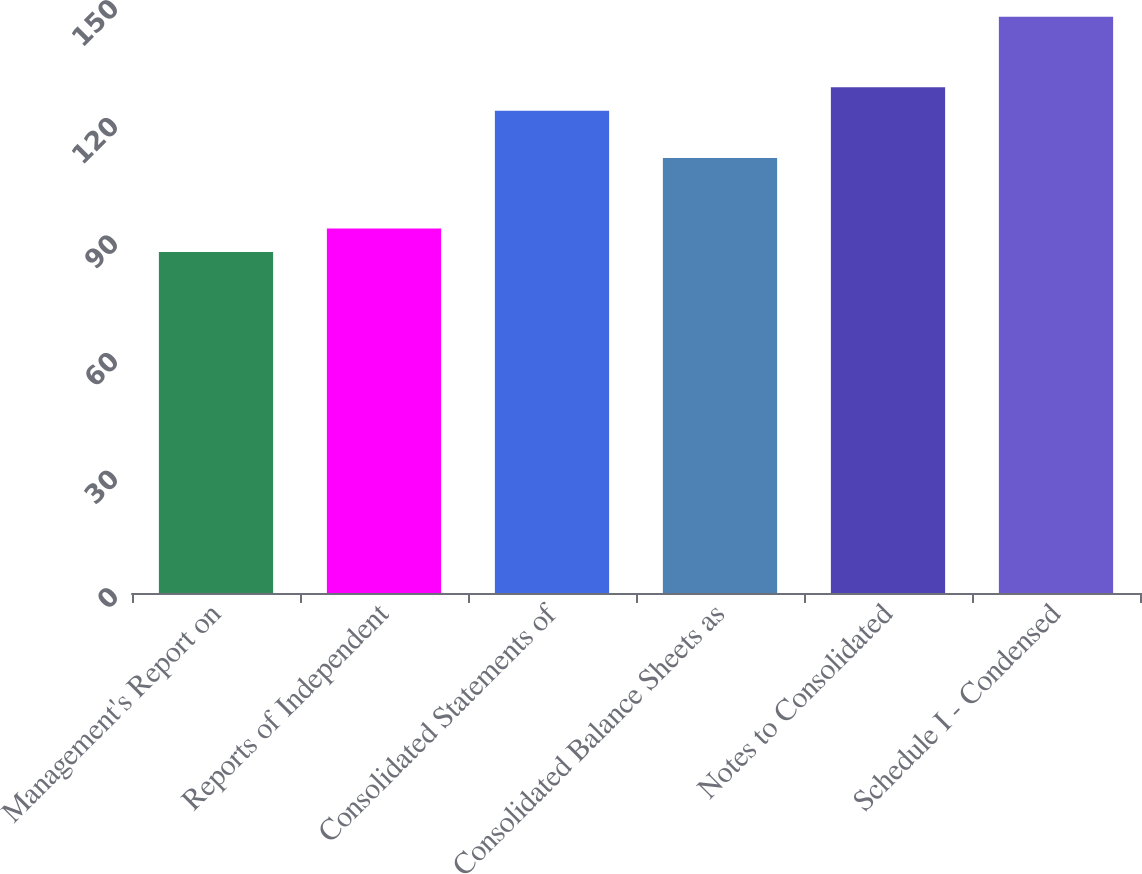Convert chart to OTSL. <chart><loc_0><loc_0><loc_500><loc_500><bar_chart><fcel>Management's Report on<fcel>Reports of Independent<fcel>Consolidated Statements of<fcel>Consolidated Balance Sheets as<fcel>Notes to Consolidated<fcel>Schedule I - Condensed<nl><fcel>87<fcel>93<fcel>123<fcel>111<fcel>129<fcel>147<nl></chart> 